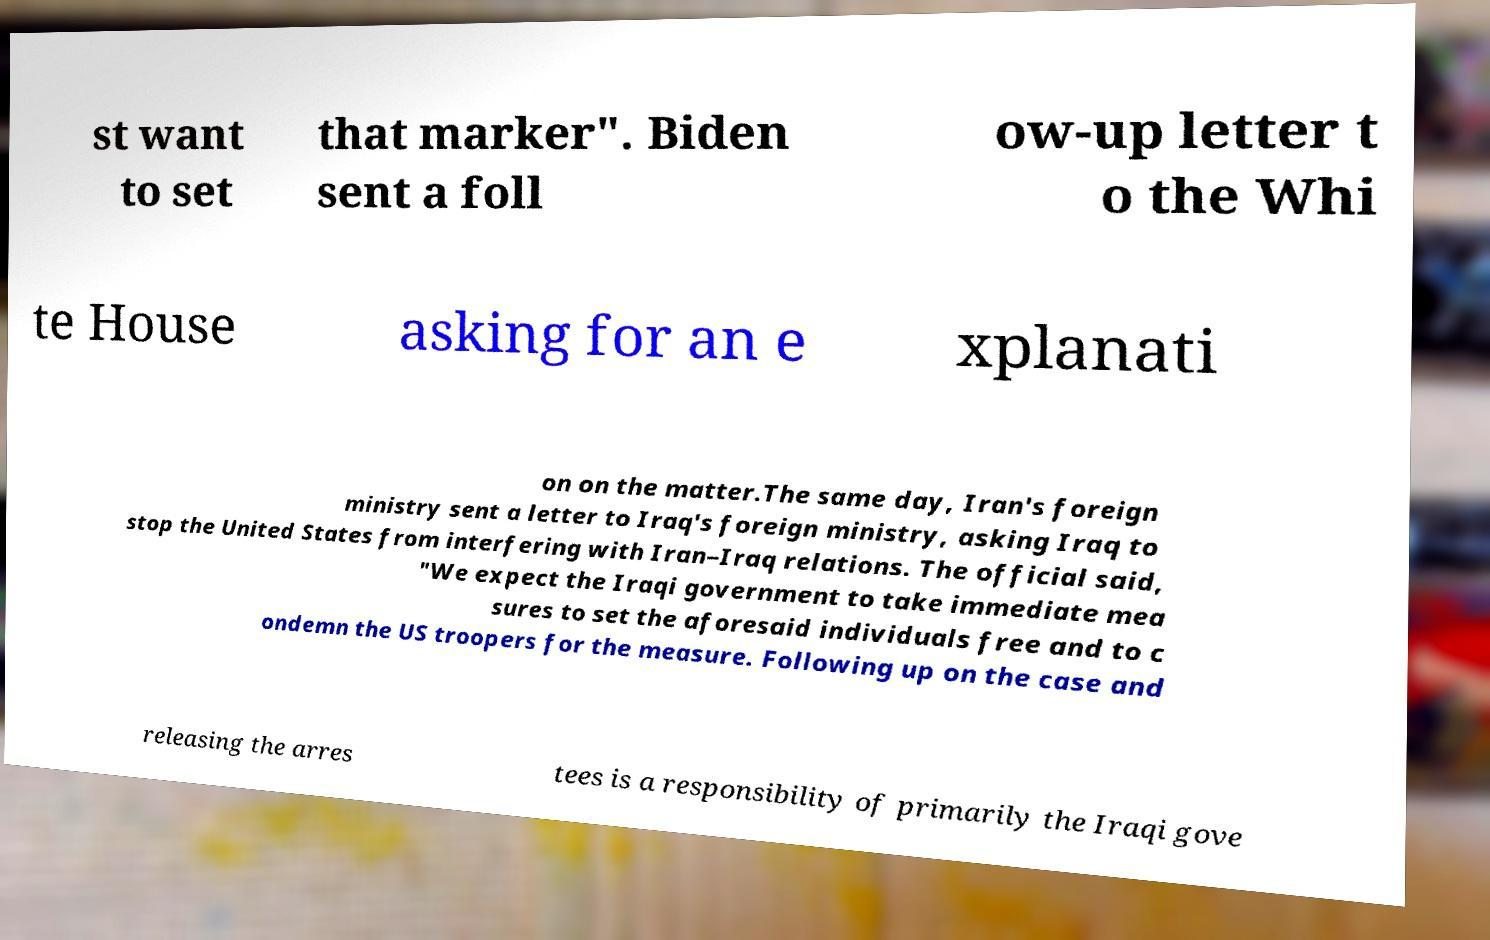For documentation purposes, I need the text within this image transcribed. Could you provide that? st want to set that marker". Biden sent a foll ow-up letter t o the Whi te House asking for an e xplanati on on the matter.The same day, Iran's foreign ministry sent a letter to Iraq's foreign ministry, asking Iraq to stop the United States from interfering with Iran–Iraq relations. The official said, "We expect the Iraqi government to take immediate mea sures to set the aforesaid individuals free and to c ondemn the US troopers for the measure. Following up on the case and releasing the arres tees is a responsibility of primarily the Iraqi gove 